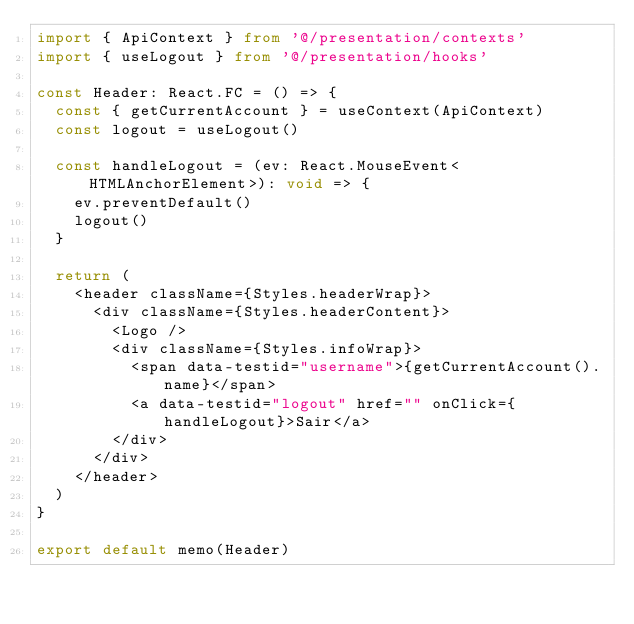<code> <loc_0><loc_0><loc_500><loc_500><_TypeScript_>import { ApiContext } from '@/presentation/contexts'
import { useLogout } from '@/presentation/hooks'

const Header: React.FC = () => {
  const { getCurrentAccount } = useContext(ApiContext)
  const logout = useLogout()

  const handleLogout = (ev: React.MouseEvent<HTMLAnchorElement>): void => {
    ev.preventDefault()
    logout()
  }

  return (
    <header className={Styles.headerWrap}>
      <div className={Styles.headerContent}>
        <Logo />
        <div className={Styles.infoWrap}>
          <span data-testid="username">{getCurrentAccount().name}</span>
          <a data-testid="logout" href="" onClick={handleLogout}>Sair</a>
        </div>
      </div>
    </header>
  )
}

export default memo(Header)
</code> 